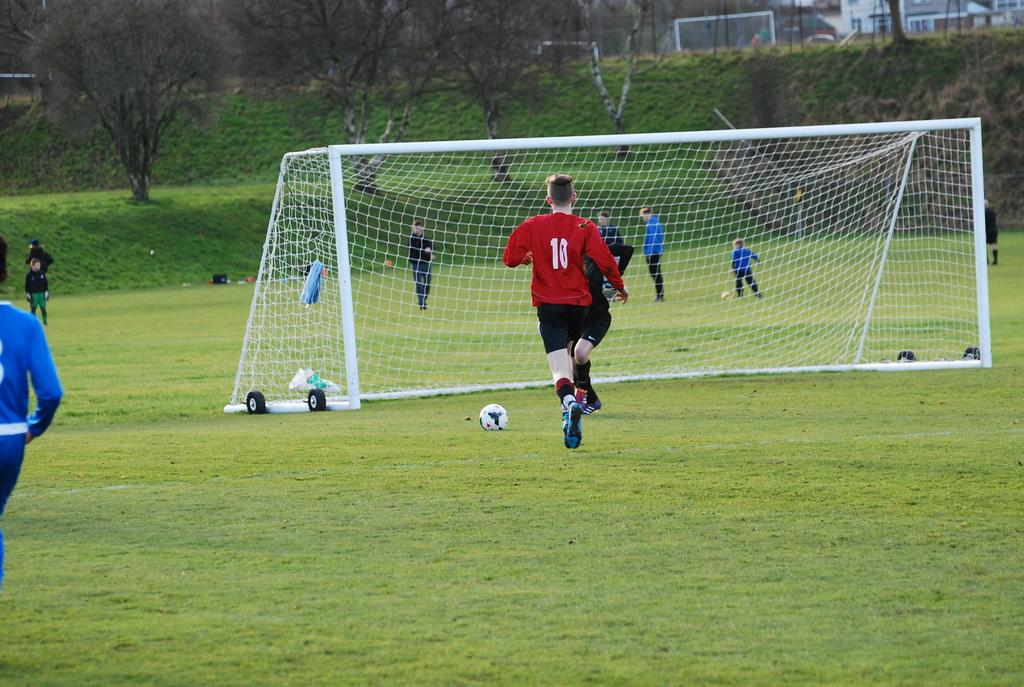<image>
Describe the image concisely. soccer field with several players in the background and number 11 in red running toward the goal 